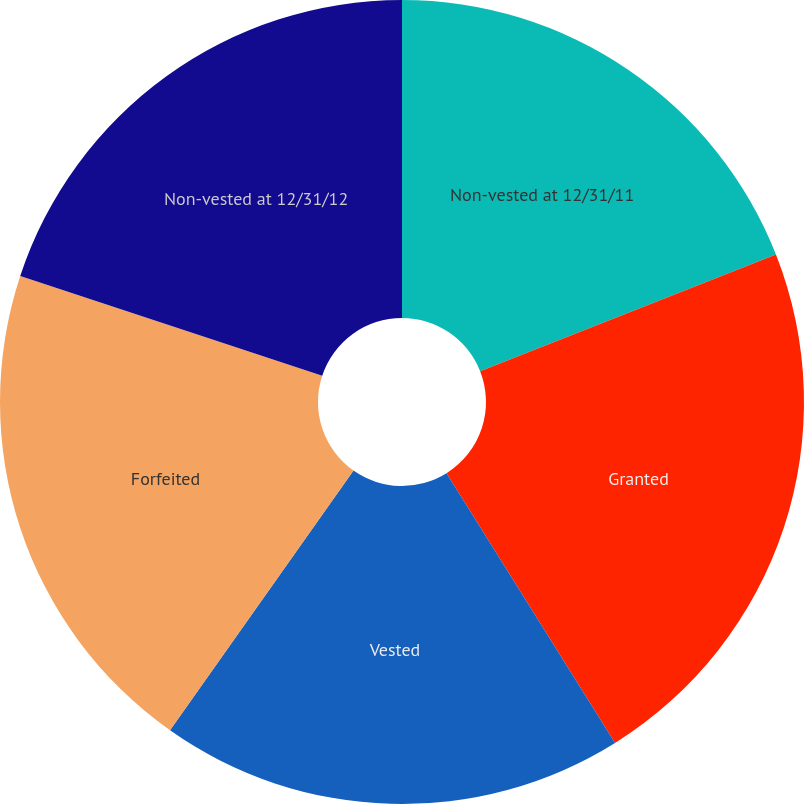Convert chart. <chart><loc_0><loc_0><loc_500><loc_500><pie_chart><fcel>Non-vested at 12/31/11<fcel>Granted<fcel>Vested<fcel>Forfeited<fcel>Non-vested at 12/31/12<nl><fcel>19.02%<fcel>22.09%<fcel>18.68%<fcel>20.28%<fcel>19.93%<nl></chart> 